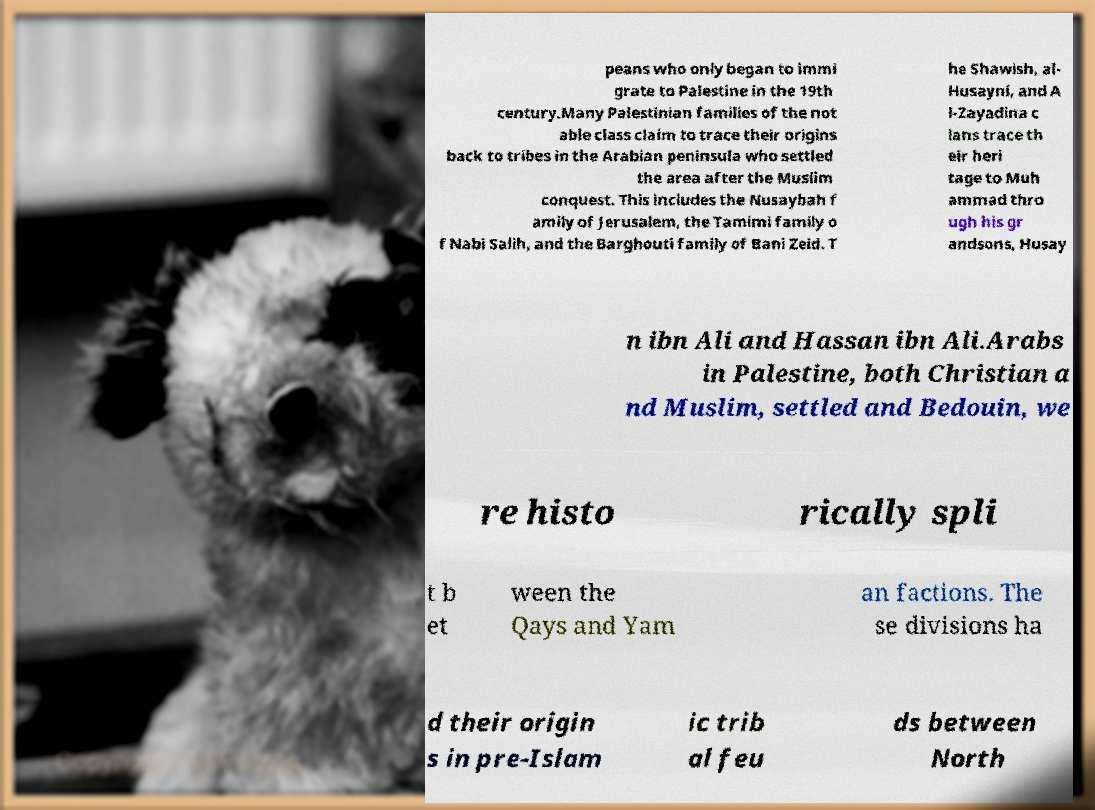For documentation purposes, I need the text within this image transcribed. Could you provide that? peans who only began to immi grate to Palestine in the 19th century.Many Palestinian families of the not able class claim to trace their origins back to tribes in the Arabian peninsula who settled the area after the Muslim conquest. This includes the Nusaybah f amily of Jerusalem, the Tamimi family o f Nabi Salih, and the Barghouti family of Bani Zeid. T he Shawish, al- Husayni, and A l-Zayadina c lans trace th eir heri tage to Muh ammad thro ugh his gr andsons, Husay n ibn Ali and Hassan ibn Ali.Arabs in Palestine, both Christian a nd Muslim, settled and Bedouin, we re histo rically spli t b et ween the Qays and Yam an factions. The se divisions ha d their origin s in pre-Islam ic trib al feu ds between North 